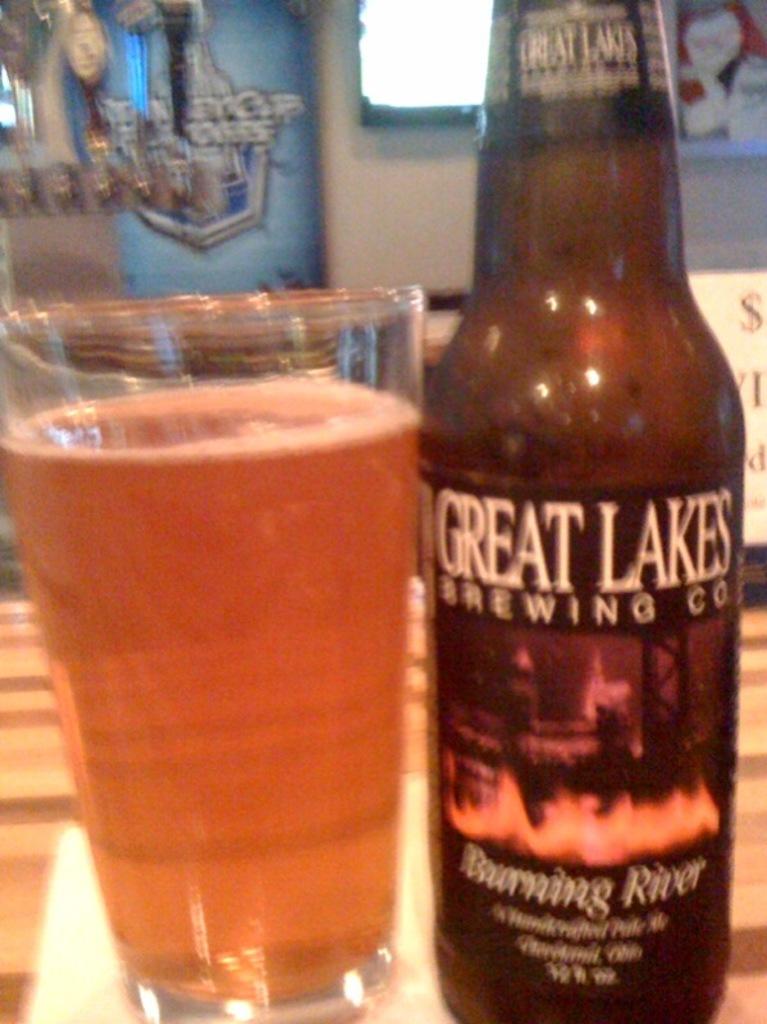Which company makes this beverage?
Offer a terse response. Great lakes brewing co. What is the name of this beverage?
Offer a terse response. Burning river. 